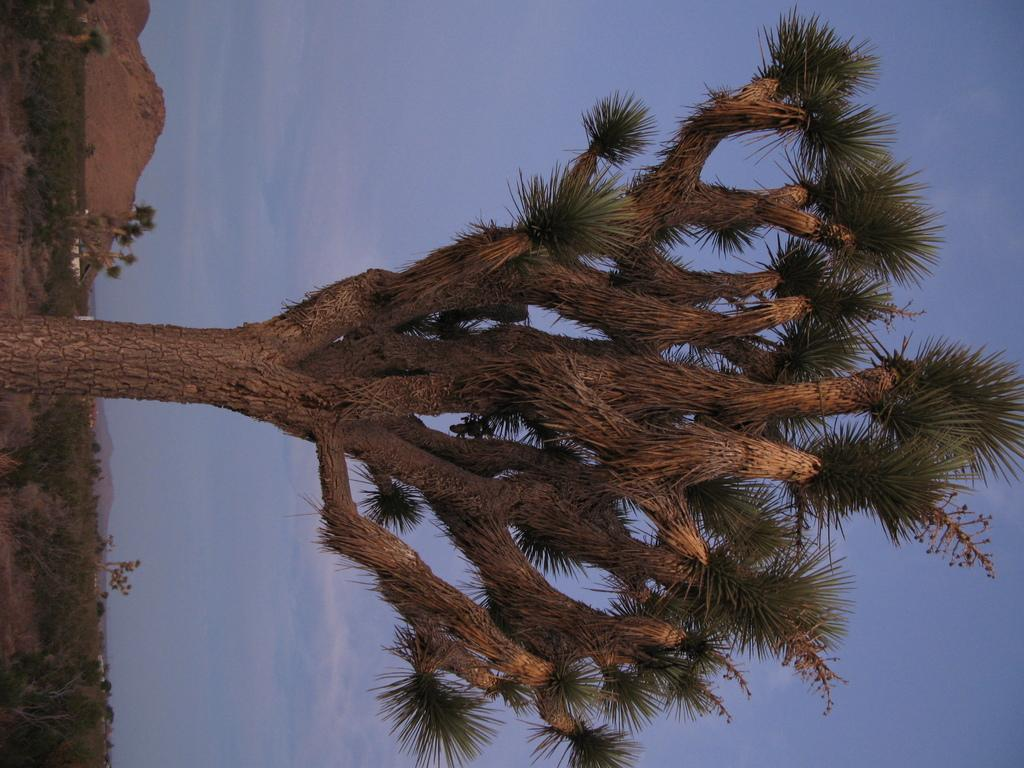What type of vegetation can be seen in the image? There are trees and plants in the image. What type of natural landform is visible in the image? There are mountains in the image. What is visible in the background of the image? The sky is visible in the background of the image. What can be seen in the sky in the image? Clouds are present in the sky. What type of fruit is hanging from the trees in the image? There is no fruit visible in the image; only trees, plants, mountains, sky, and clouds are present. 